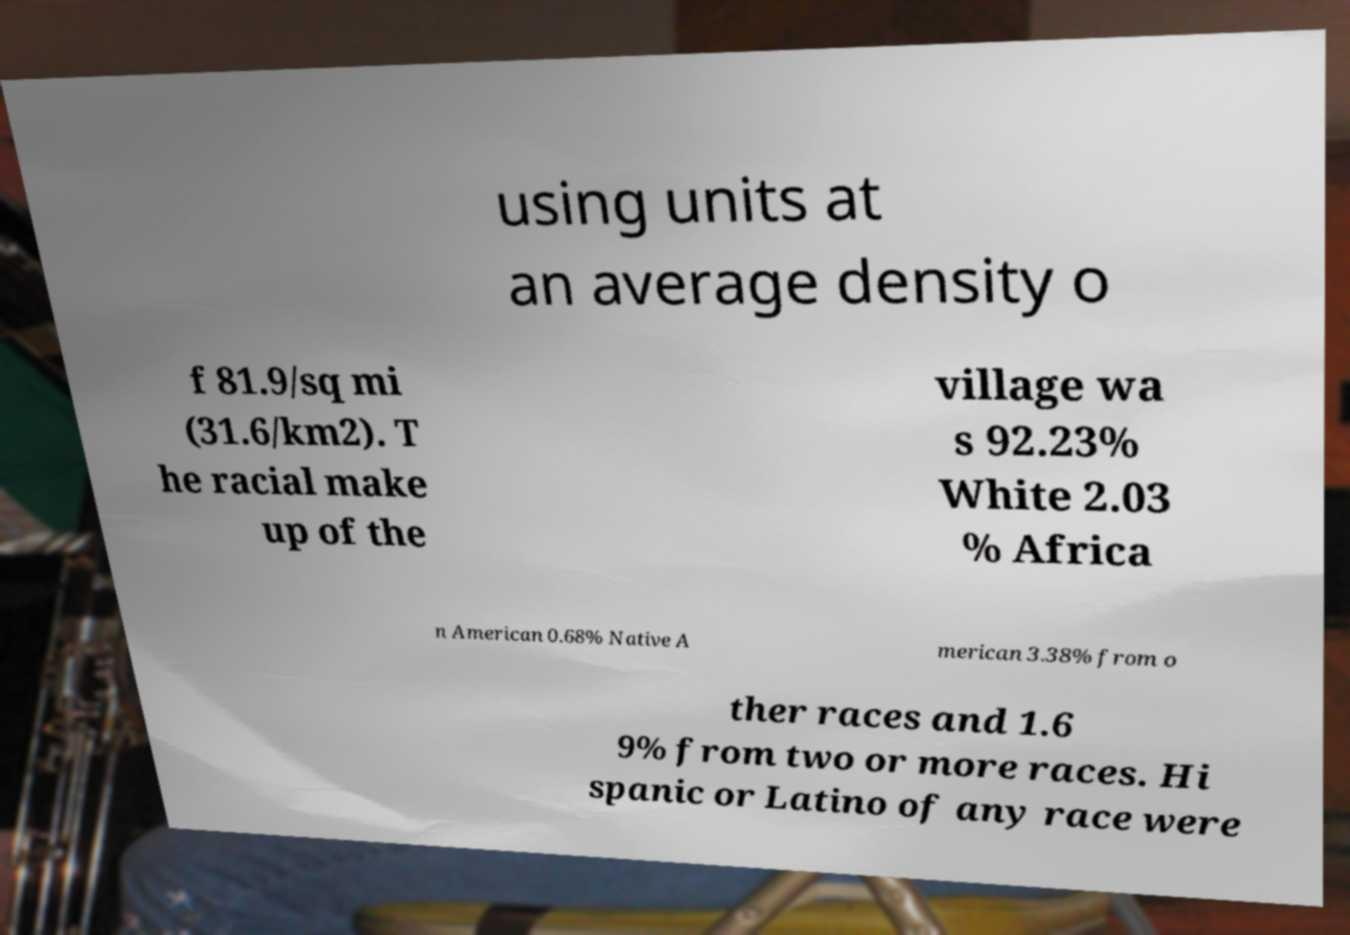Please read and relay the text visible in this image. What does it say? using units at an average density o f 81.9/sq mi (31.6/km2). T he racial make up of the village wa s 92.23% White 2.03 % Africa n American 0.68% Native A merican 3.38% from o ther races and 1.6 9% from two or more races. Hi spanic or Latino of any race were 